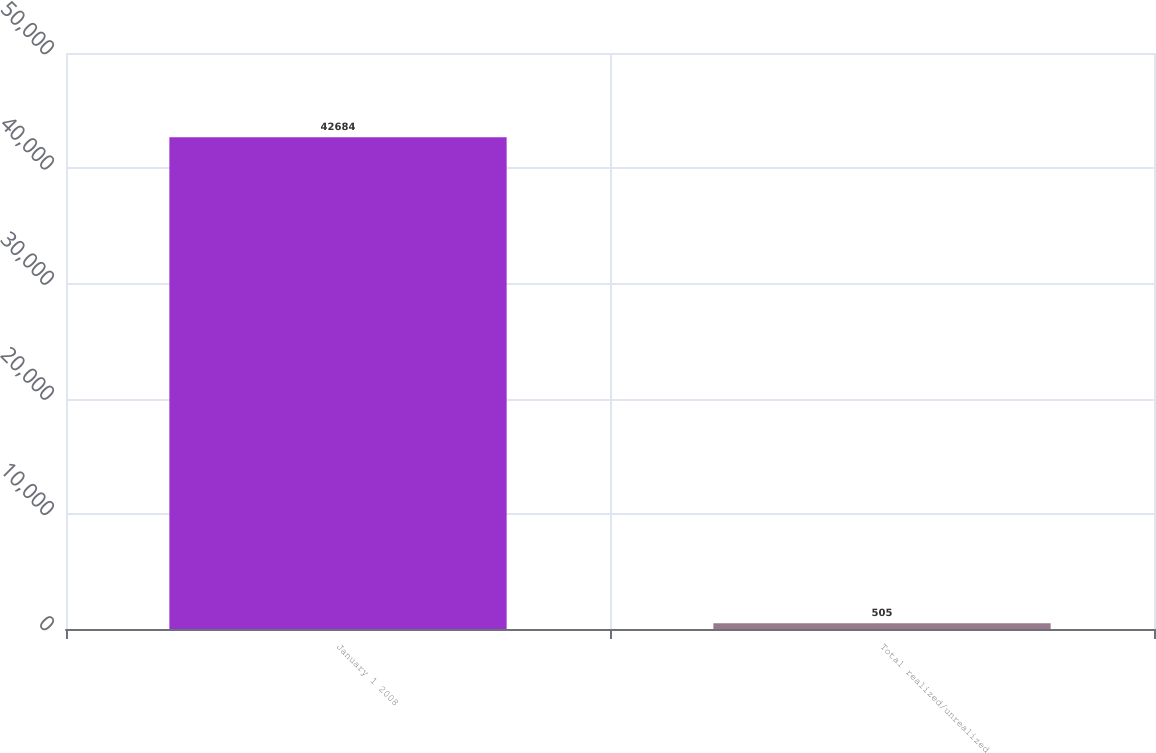Convert chart. <chart><loc_0><loc_0><loc_500><loc_500><bar_chart><fcel>January 1 2008<fcel>Total realized/unrealized<nl><fcel>42684<fcel>505<nl></chart> 